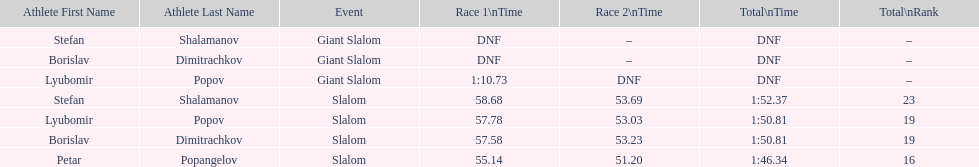Who has the highest rank? Petar Popangelov. 